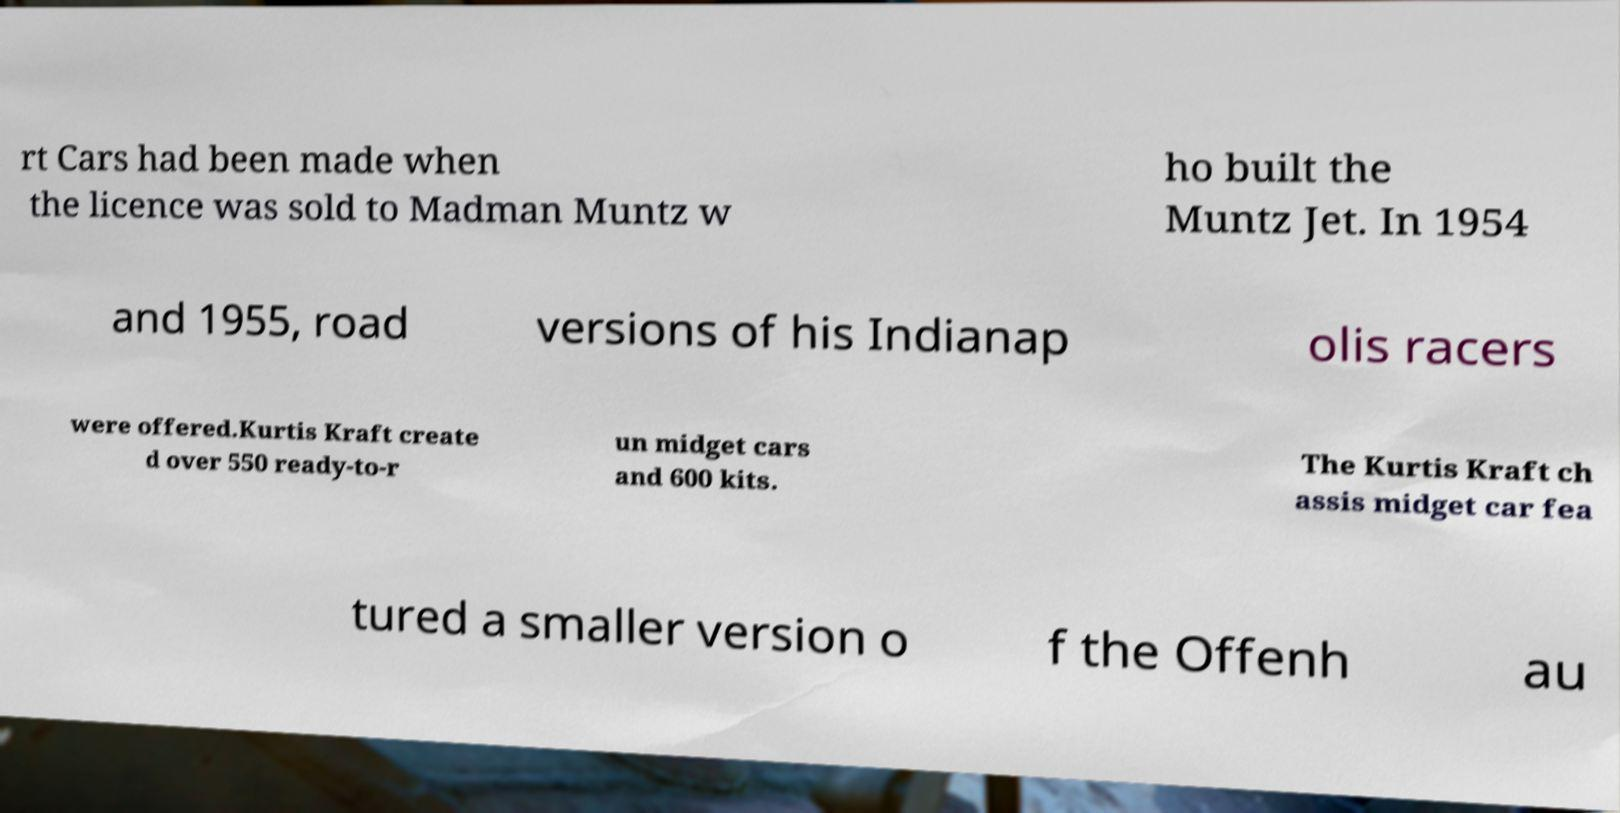Please read and relay the text visible in this image. What does it say? rt Cars had been made when the licence was sold to Madman Muntz w ho built the Muntz Jet. In 1954 and 1955, road versions of his Indianap olis racers were offered.Kurtis Kraft create d over 550 ready-to-r un midget cars and 600 kits. The Kurtis Kraft ch assis midget car fea tured a smaller version o f the Offenh au 